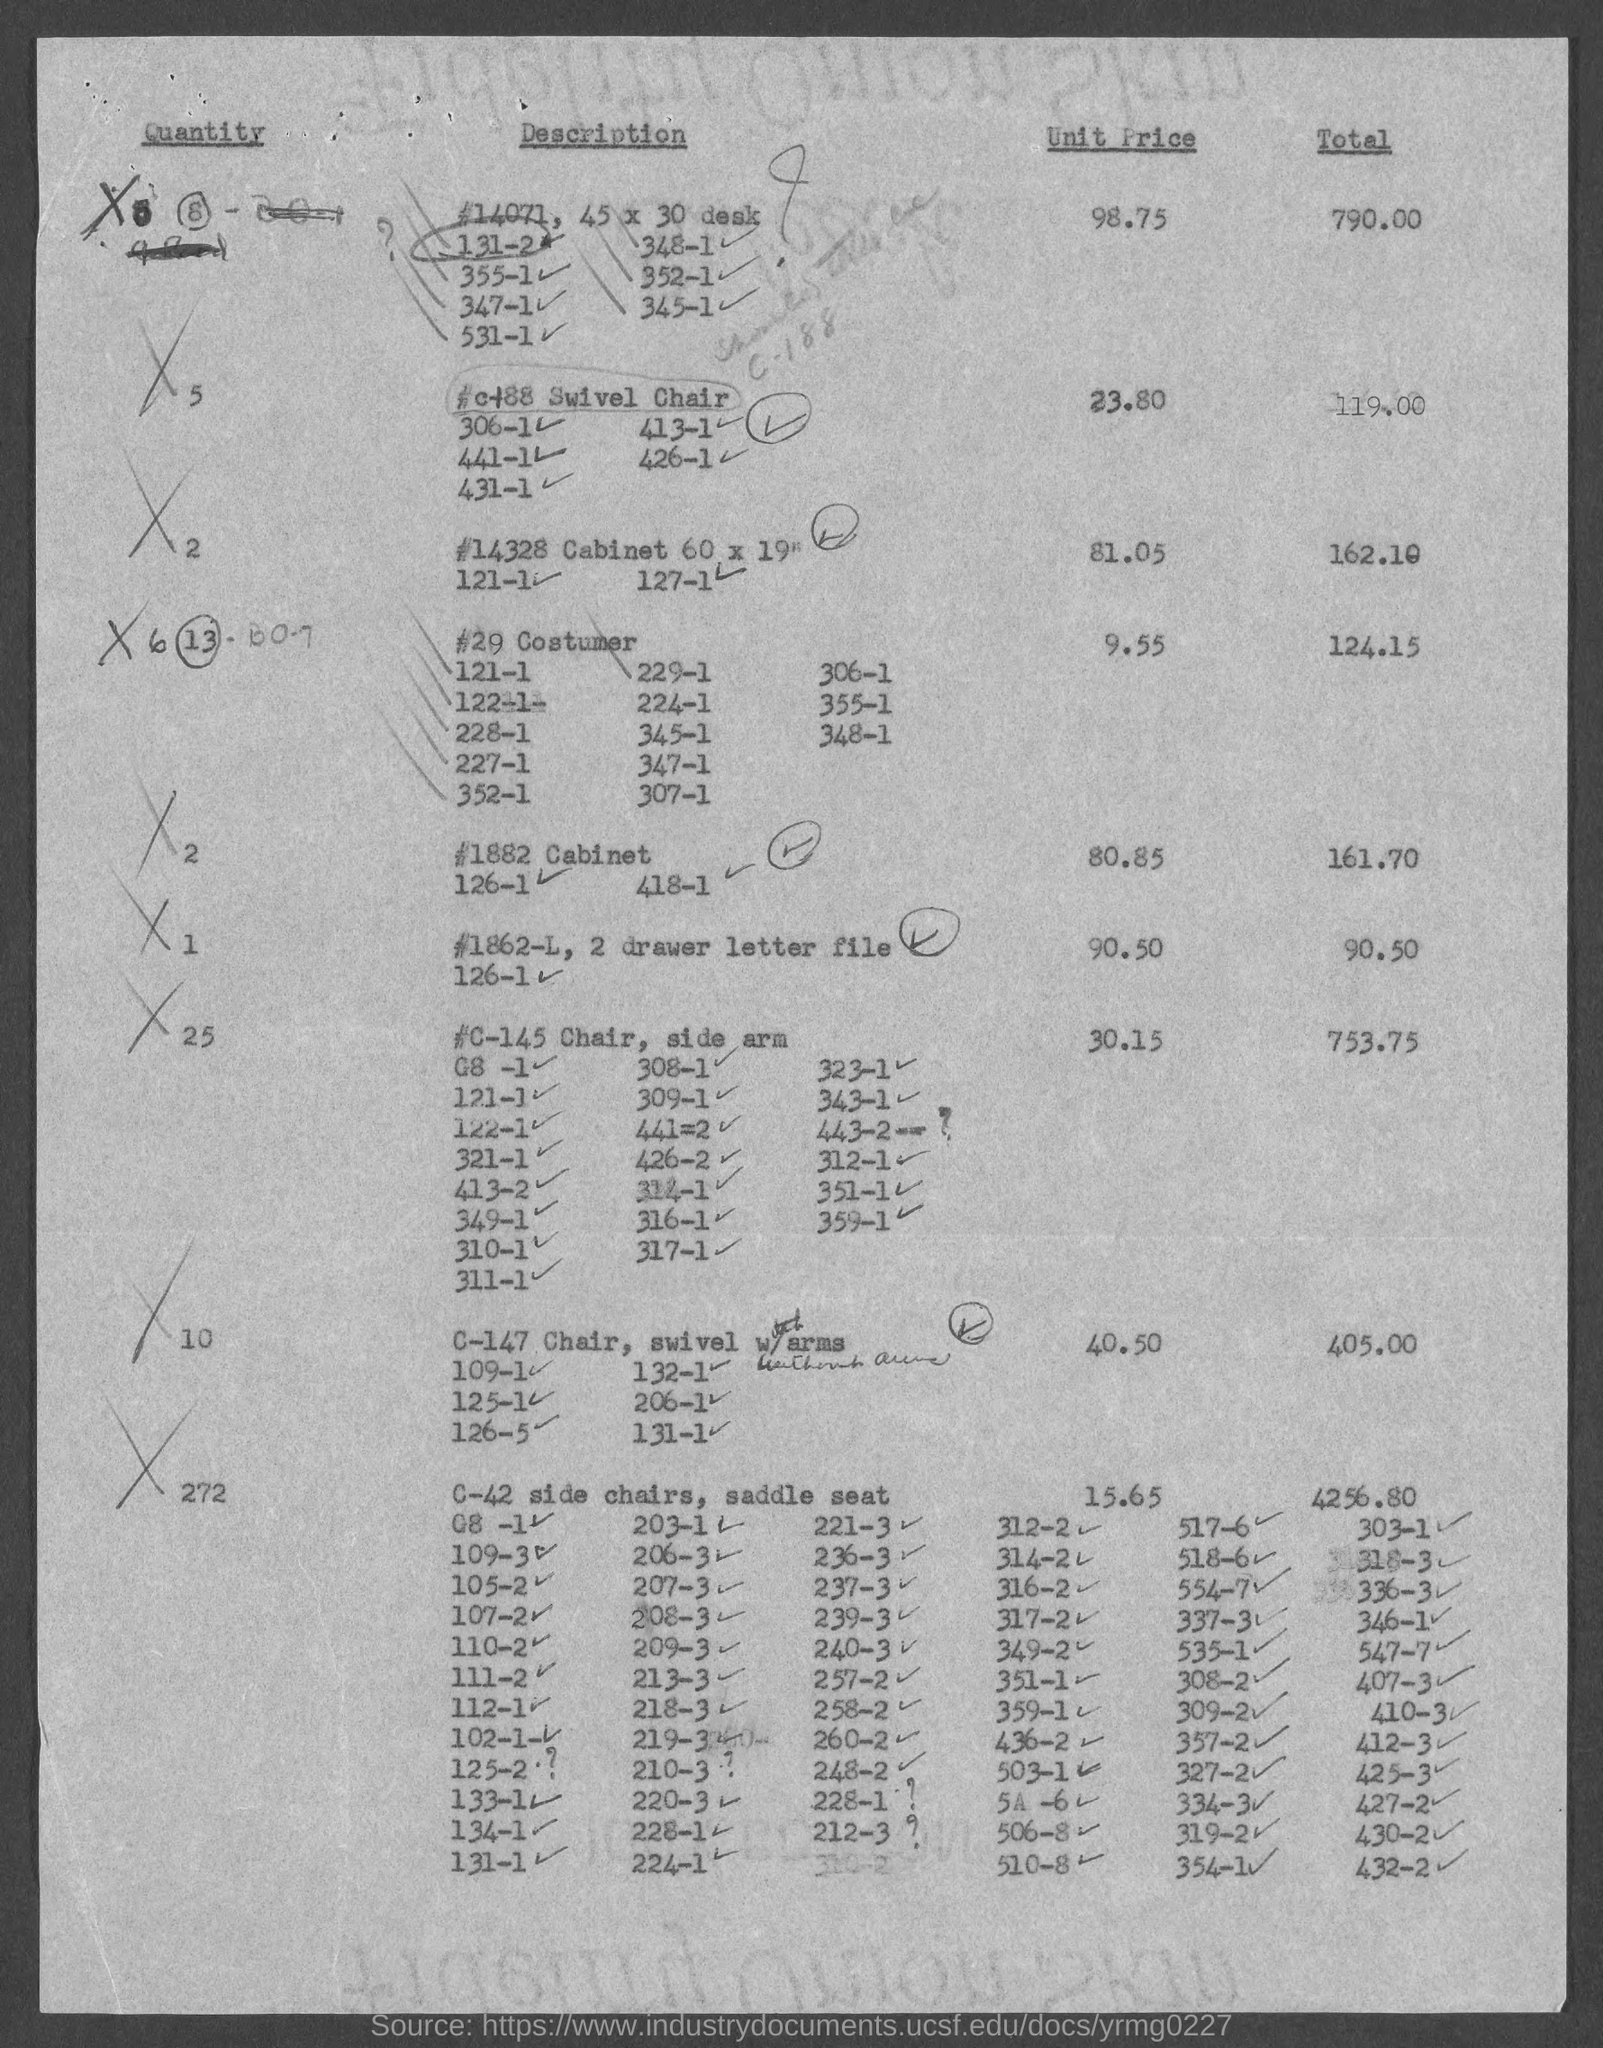Point out several critical features in this image. The unit price for a quantity of 10 is 40.50. The unit price for quantity "1" is 90.50. The total value for quantity 25 is 753.75. 